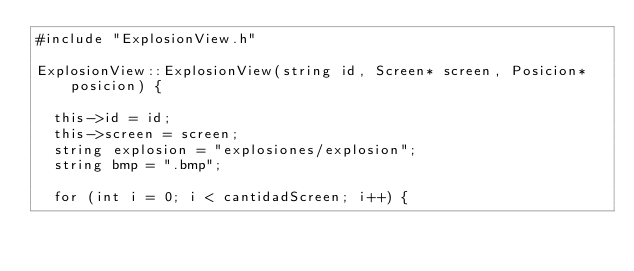Convert code to text. <code><loc_0><loc_0><loc_500><loc_500><_C++_>#include "ExplosionView.h"

ExplosionView::ExplosionView(string id, Screen* screen, Posicion* posicion) {

	this->id = id;
	this->screen = screen;
	string explosion = "explosiones/explosion";
	string bmp = ".bmp";

	for (int i = 0; i < cantidadScreen; i++) {</code> 